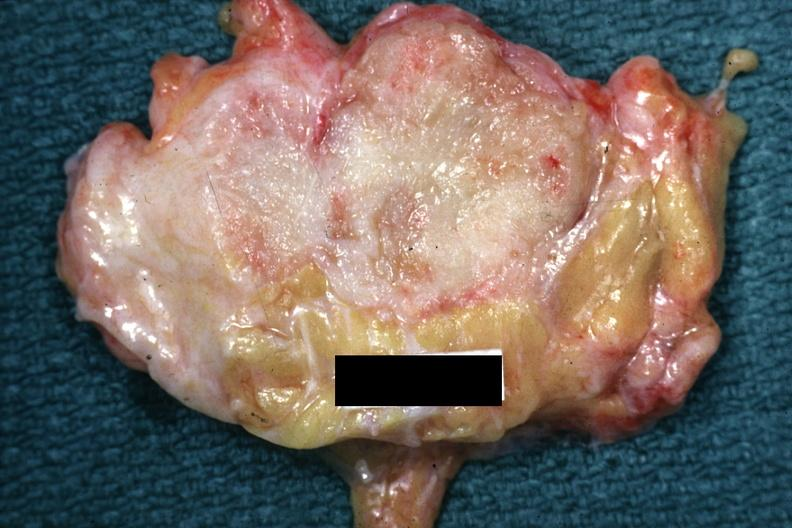s slide labeled cystosarcoma?
Answer the question using a single word or phrase. Yes 